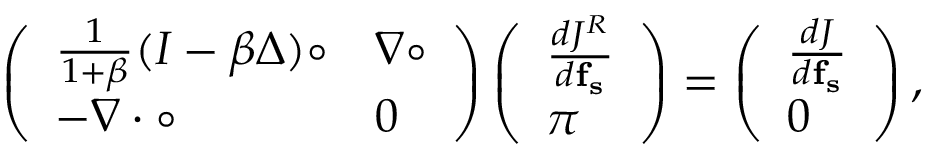Convert formula to latex. <formula><loc_0><loc_0><loc_500><loc_500>\left ( \begin{array} { l l } { \frac { 1 } { 1 + \beta } ( I - \beta \Delta ) \circ } & { \nabla \circ } \\ { - \nabla \cdot \circ } & { 0 } \end{array} \right ) \left ( \begin{array} { l } { \frac { d J ^ { R } } { d f _ { s } } } \\ { \pi } \end{array} \right ) = \left ( \begin{array} { l } { \frac { d J } { d f _ { s } } } \\ { 0 } \end{array} \right ) ,</formula> 